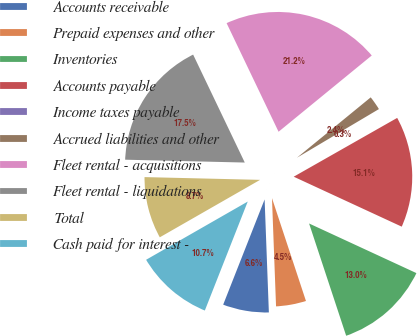Convert chart. <chart><loc_0><loc_0><loc_500><loc_500><pie_chart><fcel>Accounts receivable<fcel>Prepaid expenses and other<fcel>Inventories<fcel>Accounts payable<fcel>Income taxes payable<fcel>Accrued liabilities and other<fcel>Fleet rental - acquisitions<fcel>Fleet rental - liquidations<fcel>Total<fcel>Cash paid for interest -<nl><fcel>6.57%<fcel>4.48%<fcel>13.03%<fcel>15.12%<fcel>0.3%<fcel>2.39%<fcel>21.19%<fcel>17.52%<fcel>8.66%<fcel>10.75%<nl></chart> 